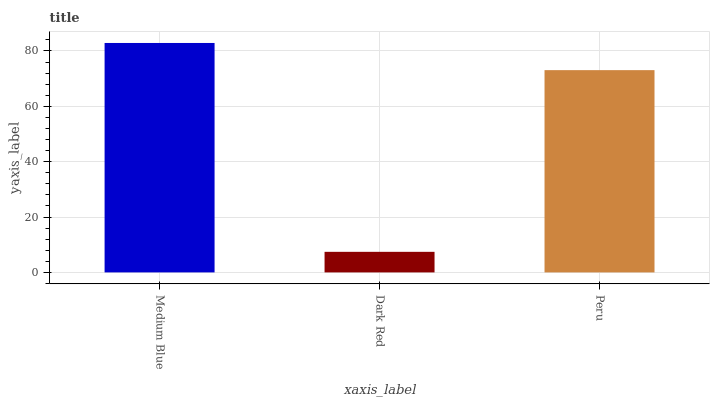Is Dark Red the minimum?
Answer yes or no. Yes. Is Medium Blue the maximum?
Answer yes or no. Yes. Is Peru the minimum?
Answer yes or no. No. Is Peru the maximum?
Answer yes or no. No. Is Peru greater than Dark Red?
Answer yes or no. Yes. Is Dark Red less than Peru?
Answer yes or no. Yes. Is Dark Red greater than Peru?
Answer yes or no. No. Is Peru less than Dark Red?
Answer yes or no. No. Is Peru the high median?
Answer yes or no. Yes. Is Peru the low median?
Answer yes or no. Yes. Is Dark Red the high median?
Answer yes or no. No. Is Medium Blue the low median?
Answer yes or no. No. 